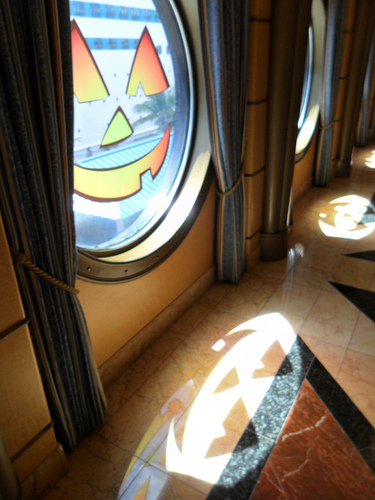<image>
Is the window above the pumpkin face? No. The window is not positioned above the pumpkin face. The vertical arrangement shows a different relationship. 